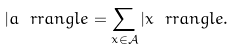<formula> <loc_0><loc_0><loc_500><loc_500>| a \ r r a n g l e = \sum _ { x \in { \mathcal { A } } } | x \ r r a n g l e .</formula> 